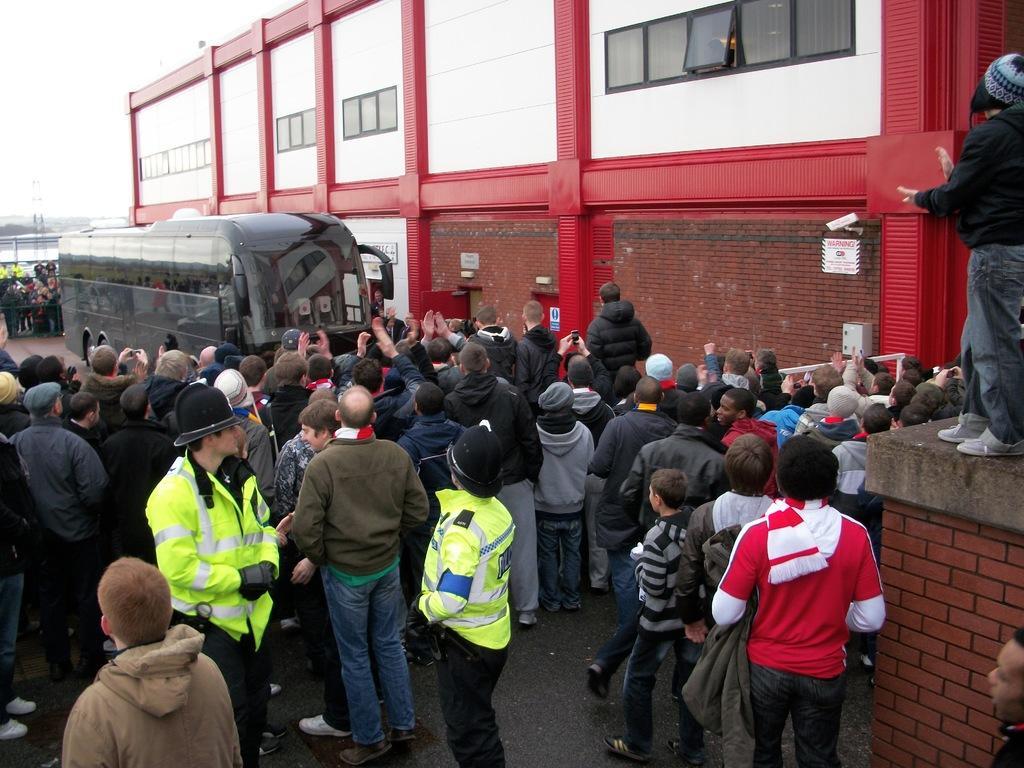In one or two sentences, can you explain what this image depicts? In this image we can see a group of people wearing dress are standing on the ground. Two persons are wearing uniforms and helmets. To the left side of the image we can see bus placed on the ground. In the background, we can see a building with windows and the sky. 